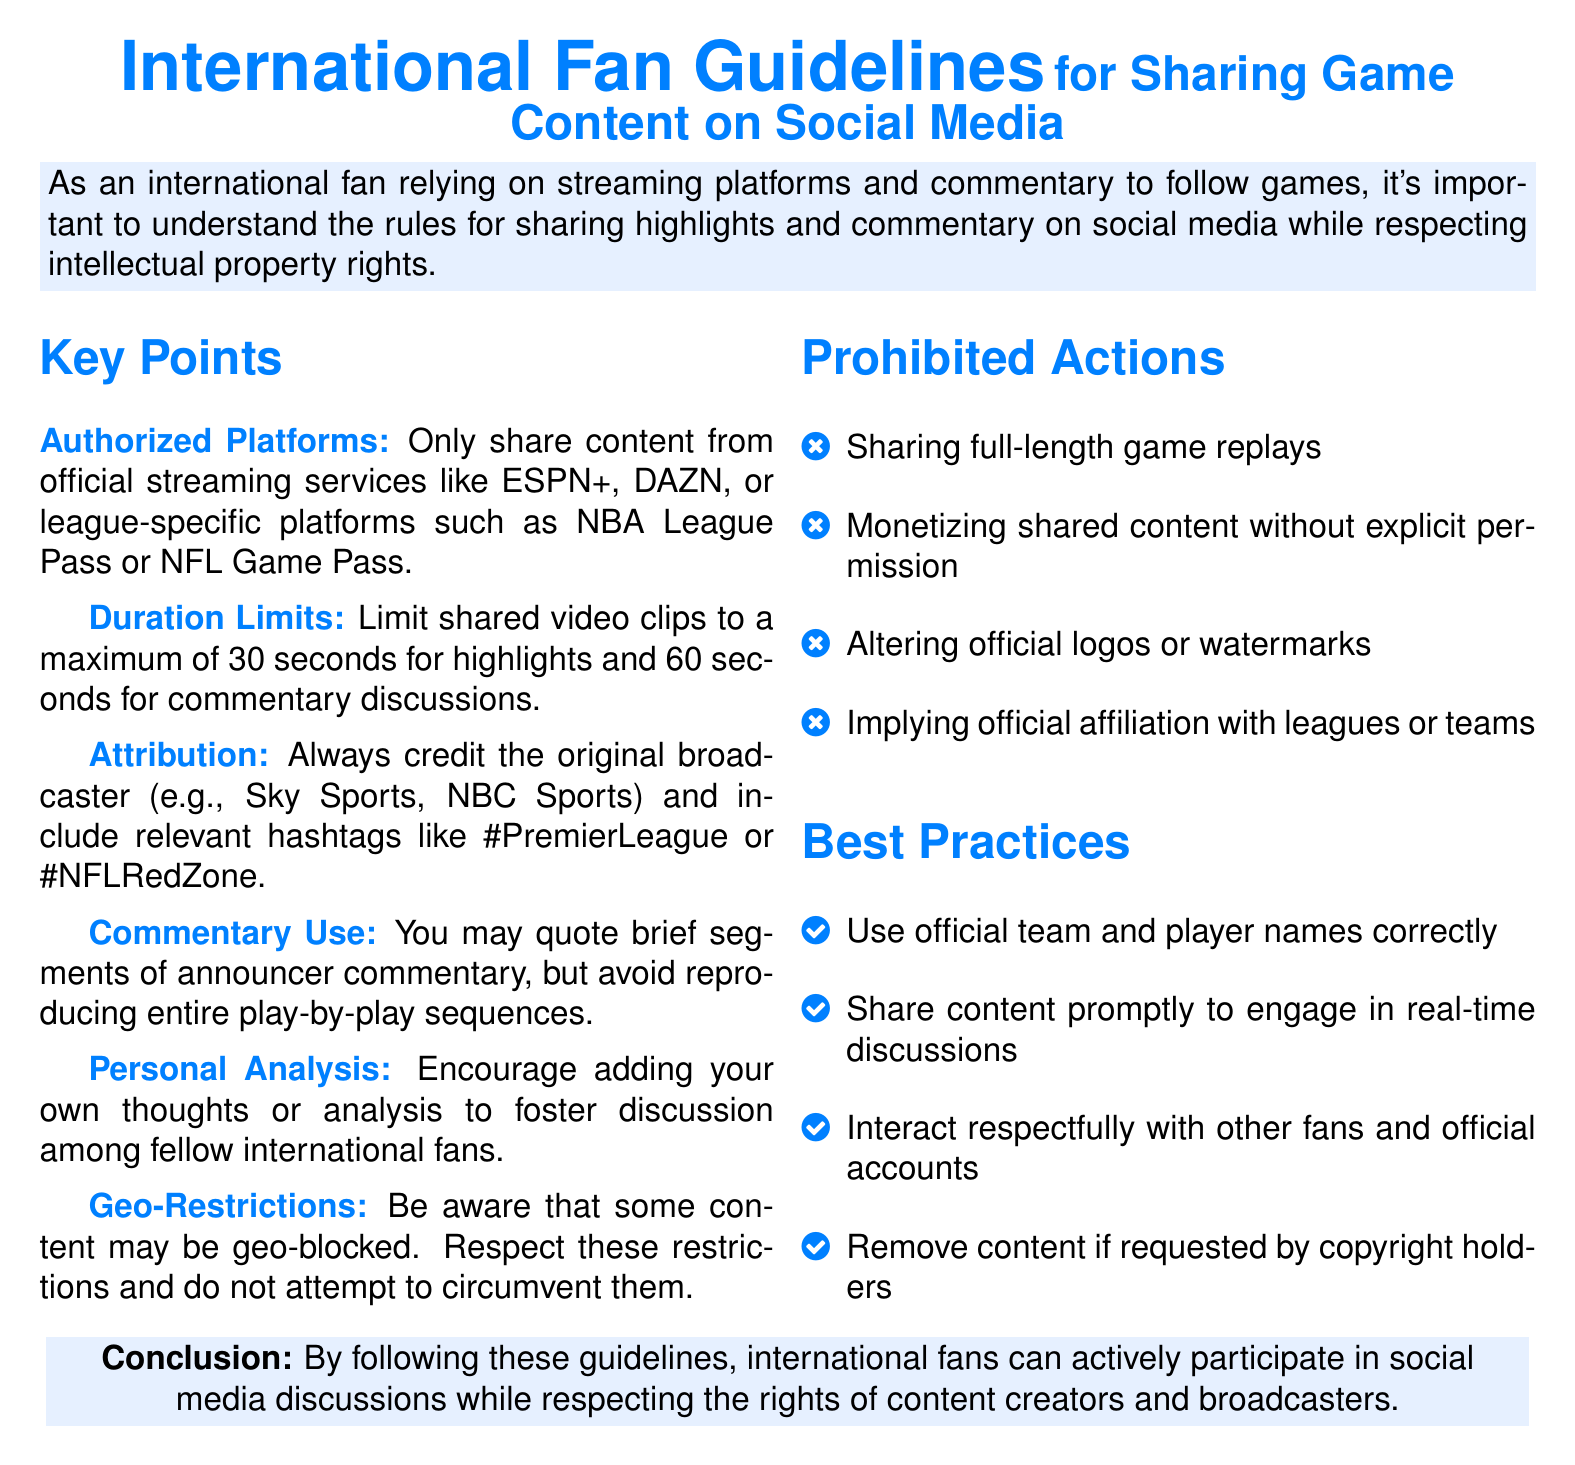What is the maximum duration for shared video clips of highlights? The document states that shared video clips of highlights should be limited to a maximum duration of 30 seconds.
Answer: 30 seconds Who should be credited when sharing content? The policy emphasizes that the original broadcaster must always be credited when content is shared.
Answer: Original broadcaster What is prohibited regarding game replays? The document clearly states that sharing full-length game replays is prohibited.
Answer: Full-length game replays How long can commentary discussions be shared? According to the guidelines, commentary discussions can be shared for a maximum of 60 seconds.
Answer: 60 seconds What kind of content can be shared from official streaming services? The guidelines specify that only content from authorized official streaming services should be shared.
Answer: Authorized official streaming services What is encouraged when sharing personal analysis? The document encourages fans to add their thoughts or analysis to foster discussion.
Answer: Adding thoughts or analysis What should fans do if requested by copyright holders? Fans are advised to remove content if requested by copyright holders.
Answer: Remove content Are there any geo-restrictions mentioned? Yes, the document mentions that some content may be geo-blocked and encourages respect for these restrictions.
Answer: Geo-blocked What types of logos or watermarks are prohibited to alter? The policy prohibits altering official logos or watermarks when sharing content.
Answer: Official logos or watermarks 